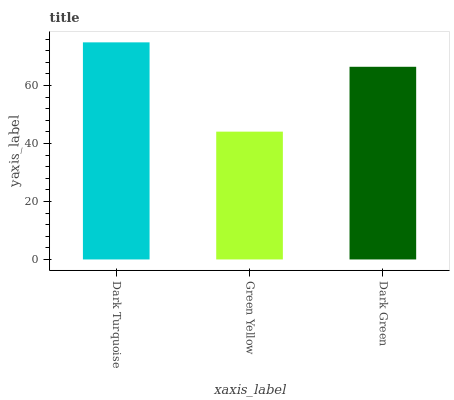Is Green Yellow the minimum?
Answer yes or no. Yes. Is Dark Turquoise the maximum?
Answer yes or no. Yes. Is Dark Green the minimum?
Answer yes or no. No. Is Dark Green the maximum?
Answer yes or no. No. Is Dark Green greater than Green Yellow?
Answer yes or no. Yes. Is Green Yellow less than Dark Green?
Answer yes or no. Yes. Is Green Yellow greater than Dark Green?
Answer yes or no. No. Is Dark Green less than Green Yellow?
Answer yes or no. No. Is Dark Green the high median?
Answer yes or no. Yes. Is Dark Green the low median?
Answer yes or no. Yes. Is Dark Turquoise the high median?
Answer yes or no. No. Is Green Yellow the low median?
Answer yes or no. No. 